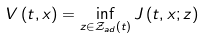Convert formula to latex. <formula><loc_0><loc_0><loc_500><loc_500>V \left ( t , x \right ) = \inf _ { z \in \mathcal { Z } _ { a d } \left ( t \right ) } J \left ( t , x ; z \right )</formula> 